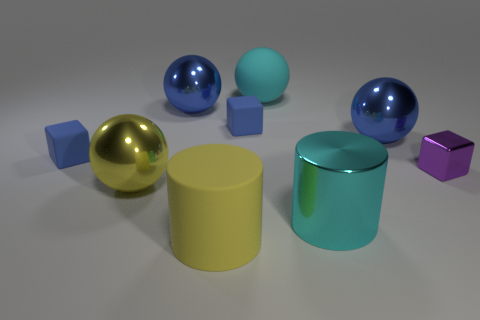What can you infer about the lighting in this scene? The lighting in this scene is soft and diffused, with no hard shadows present, indicating that the light source is not directly visible and may be large or distant. This type of lighting is often used in a studio setting to minimize shadows and create an even illumination on the subjects, suggesting a controlled environment where the objects are being deliberately presented for view or photography. 